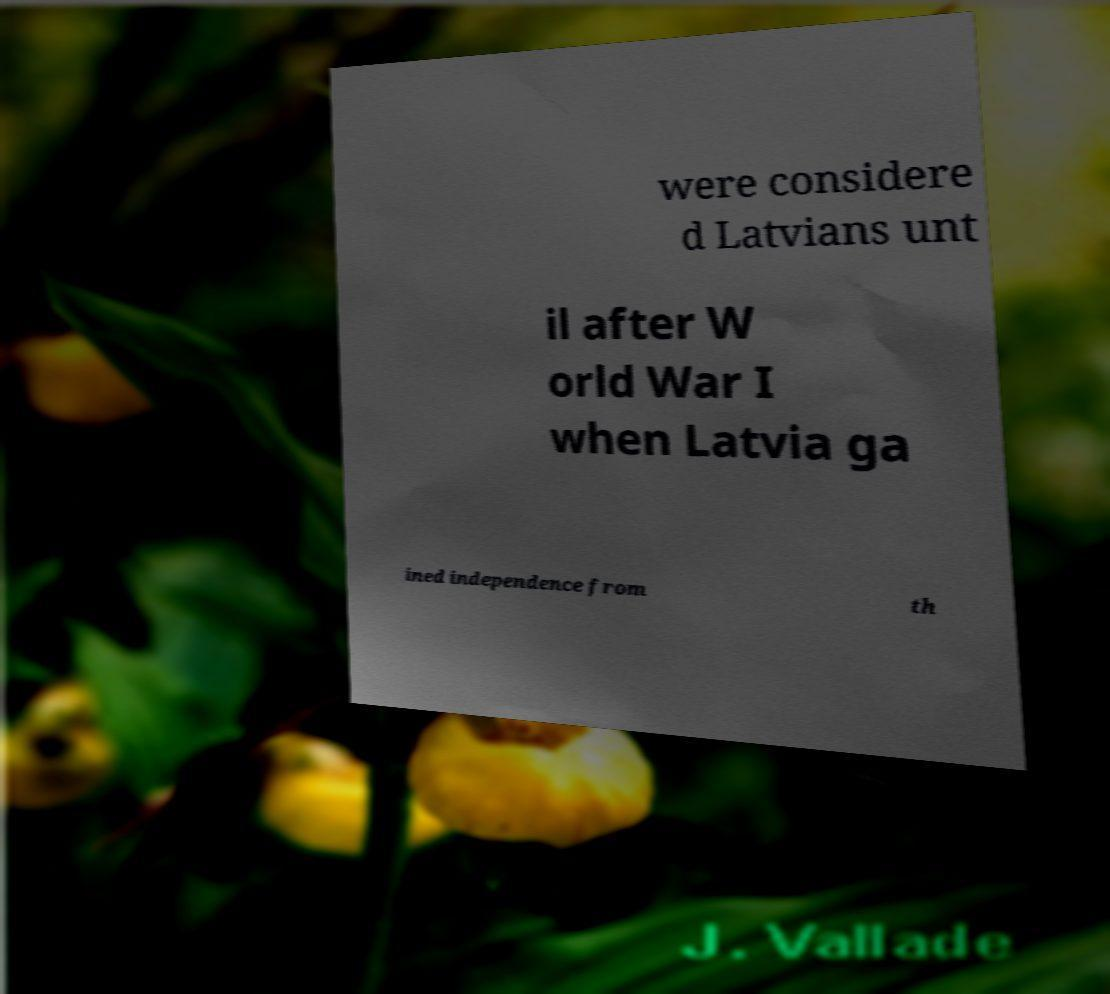Please read and relay the text visible in this image. What does it say? were considere d Latvians unt il after W orld War I when Latvia ga ined independence from th 